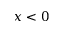Convert formula to latex. <formula><loc_0><loc_0><loc_500><loc_500>x < 0</formula> 